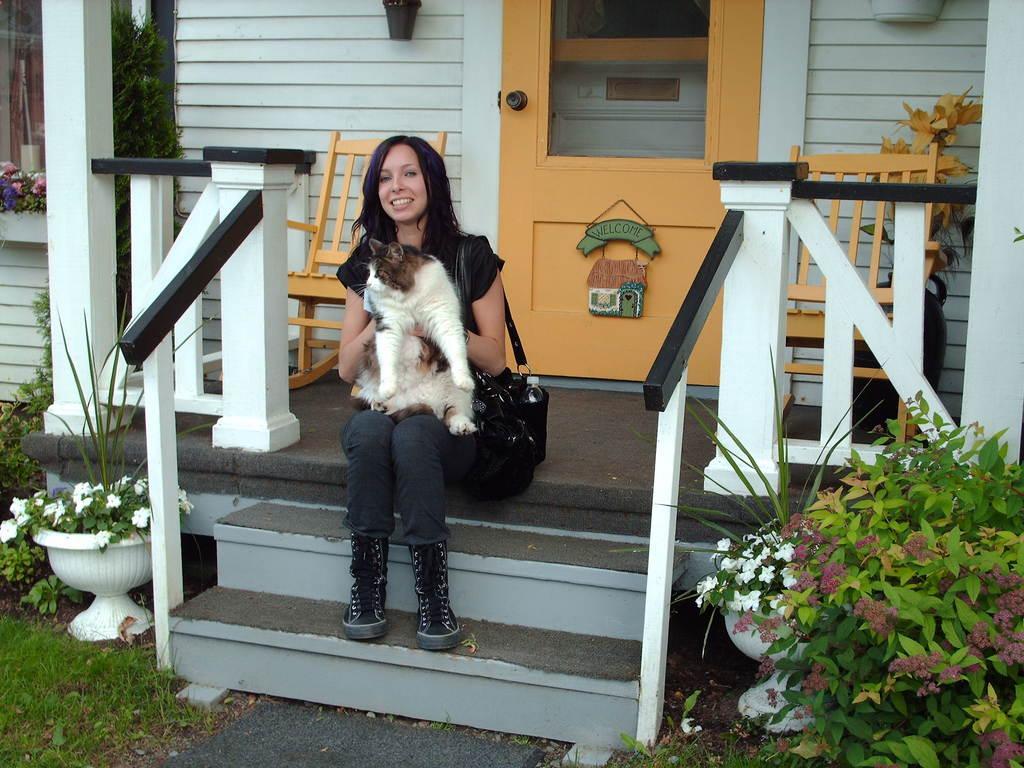Could you give a brief overview of what you see in this image? In this image I can see the person holding the cat which is in cream, black and brown color. I can see the person wearing the black color dress and black bag. I can see the bottle in the bag. To the side of the person I can see the flower pots and the plants. I can see these flowers are in white and pink color. In the background I can see the wooden chairs, door and the wall. 